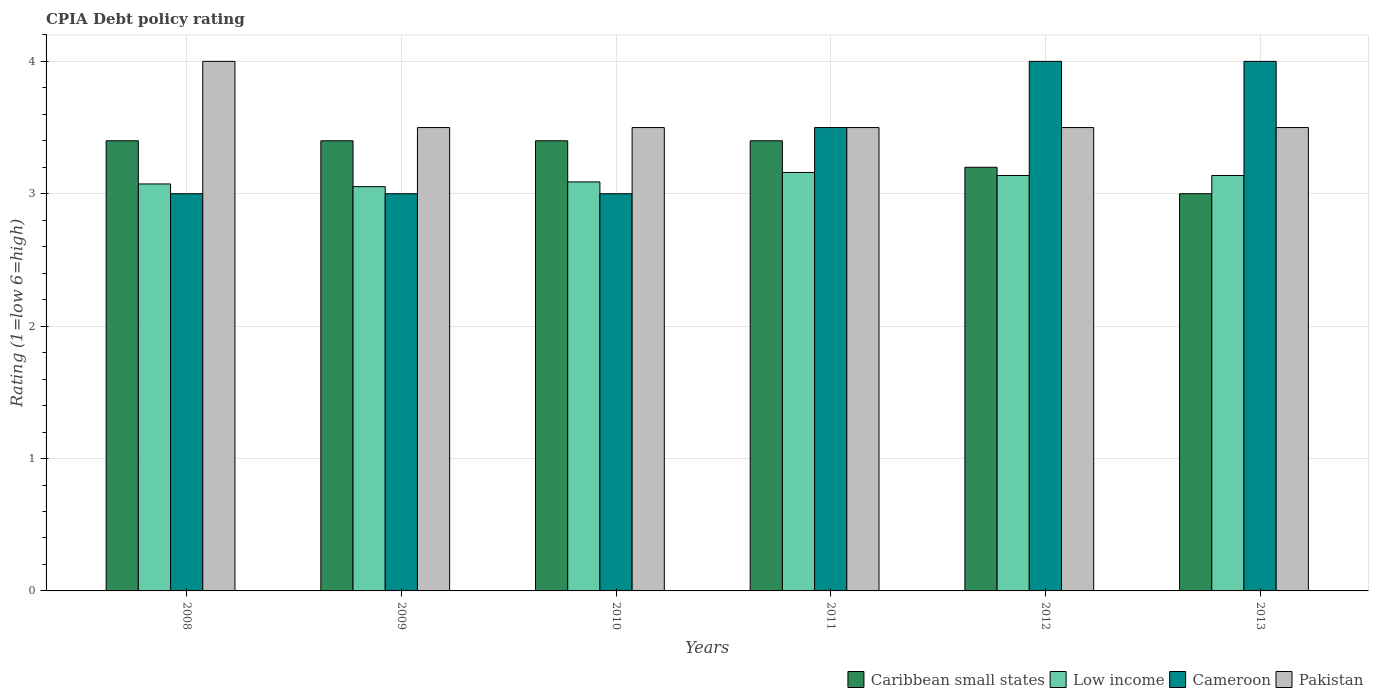How many groups of bars are there?
Offer a terse response. 6. What is the label of the 3rd group of bars from the left?
Your response must be concise. 2010. In how many cases, is the number of bars for a given year not equal to the number of legend labels?
Provide a succinct answer. 0. Across all years, what is the maximum CPIA rating in Pakistan?
Give a very brief answer. 4. Across all years, what is the minimum CPIA rating in Cameroon?
Your answer should be very brief. 3. In which year was the CPIA rating in Cameroon maximum?
Provide a succinct answer. 2012. What is the total CPIA rating in Pakistan in the graph?
Your answer should be very brief. 21.5. What is the difference between the CPIA rating in Caribbean small states in 2011 and that in 2012?
Offer a terse response. 0.2. What is the difference between the CPIA rating in Caribbean small states in 2010 and the CPIA rating in Cameroon in 2009?
Provide a succinct answer. 0.4. What is the average CPIA rating in Cameroon per year?
Your answer should be compact. 3.42. Is the difference between the CPIA rating in Cameroon in 2010 and 2013 greater than the difference between the CPIA rating in Pakistan in 2010 and 2013?
Keep it short and to the point. No. What is the difference between the highest and the second highest CPIA rating in Pakistan?
Provide a short and direct response. 0.5. What is the difference between the highest and the lowest CPIA rating in Caribbean small states?
Keep it short and to the point. 0.4. In how many years, is the CPIA rating in Caribbean small states greater than the average CPIA rating in Caribbean small states taken over all years?
Provide a short and direct response. 4. Is it the case that in every year, the sum of the CPIA rating in Low income and CPIA rating in Caribbean small states is greater than the sum of CPIA rating in Cameroon and CPIA rating in Pakistan?
Make the answer very short. No. What does the 4th bar from the left in 2011 represents?
Keep it short and to the point. Pakistan. What does the 4th bar from the right in 2008 represents?
Provide a short and direct response. Caribbean small states. How many years are there in the graph?
Provide a succinct answer. 6. Where does the legend appear in the graph?
Keep it short and to the point. Bottom right. How many legend labels are there?
Provide a short and direct response. 4. What is the title of the graph?
Your answer should be very brief. CPIA Debt policy rating. What is the label or title of the X-axis?
Provide a succinct answer. Years. What is the label or title of the Y-axis?
Give a very brief answer. Rating (1=low 6=high). What is the Rating (1=low 6=high) of Low income in 2008?
Your answer should be compact. 3.07. What is the Rating (1=low 6=high) in Pakistan in 2008?
Keep it short and to the point. 4. What is the Rating (1=low 6=high) of Caribbean small states in 2009?
Provide a succinct answer. 3.4. What is the Rating (1=low 6=high) of Low income in 2009?
Your response must be concise. 3.05. What is the Rating (1=low 6=high) in Low income in 2010?
Provide a short and direct response. 3.09. What is the Rating (1=low 6=high) in Cameroon in 2010?
Provide a succinct answer. 3. What is the Rating (1=low 6=high) in Pakistan in 2010?
Ensure brevity in your answer.  3.5. What is the Rating (1=low 6=high) of Caribbean small states in 2011?
Ensure brevity in your answer.  3.4. What is the Rating (1=low 6=high) in Low income in 2011?
Your response must be concise. 3.16. What is the Rating (1=low 6=high) of Pakistan in 2011?
Offer a very short reply. 3.5. What is the Rating (1=low 6=high) of Low income in 2012?
Provide a short and direct response. 3.14. What is the Rating (1=low 6=high) in Caribbean small states in 2013?
Your answer should be very brief. 3. What is the Rating (1=low 6=high) in Low income in 2013?
Offer a terse response. 3.14. What is the Rating (1=low 6=high) of Cameroon in 2013?
Give a very brief answer. 4. What is the Rating (1=low 6=high) of Pakistan in 2013?
Your answer should be compact. 3.5. Across all years, what is the maximum Rating (1=low 6=high) in Low income?
Give a very brief answer. 3.16. Across all years, what is the minimum Rating (1=low 6=high) of Caribbean small states?
Ensure brevity in your answer.  3. Across all years, what is the minimum Rating (1=low 6=high) in Low income?
Ensure brevity in your answer.  3.05. Across all years, what is the minimum Rating (1=low 6=high) of Cameroon?
Provide a succinct answer. 3. What is the total Rating (1=low 6=high) of Caribbean small states in the graph?
Offer a terse response. 19.8. What is the total Rating (1=low 6=high) in Low income in the graph?
Ensure brevity in your answer.  18.65. What is the total Rating (1=low 6=high) of Cameroon in the graph?
Ensure brevity in your answer.  20.5. What is the total Rating (1=low 6=high) of Pakistan in the graph?
Ensure brevity in your answer.  21.5. What is the difference between the Rating (1=low 6=high) of Caribbean small states in 2008 and that in 2009?
Offer a terse response. 0. What is the difference between the Rating (1=low 6=high) in Low income in 2008 and that in 2009?
Your answer should be compact. 0.02. What is the difference between the Rating (1=low 6=high) of Cameroon in 2008 and that in 2009?
Offer a very short reply. 0. What is the difference between the Rating (1=low 6=high) of Pakistan in 2008 and that in 2009?
Make the answer very short. 0.5. What is the difference between the Rating (1=low 6=high) in Low income in 2008 and that in 2010?
Provide a short and direct response. -0.02. What is the difference between the Rating (1=low 6=high) in Cameroon in 2008 and that in 2010?
Your answer should be very brief. 0. What is the difference between the Rating (1=low 6=high) of Caribbean small states in 2008 and that in 2011?
Offer a terse response. 0. What is the difference between the Rating (1=low 6=high) in Low income in 2008 and that in 2011?
Give a very brief answer. -0.09. What is the difference between the Rating (1=low 6=high) in Pakistan in 2008 and that in 2011?
Offer a terse response. 0.5. What is the difference between the Rating (1=low 6=high) of Low income in 2008 and that in 2012?
Offer a terse response. -0.06. What is the difference between the Rating (1=low 6=high) in Caribbean small states in 2008 and that in 2013?
Give a very brief answer. 0.4. What is the difference between the Rating (1=low 6=high) in Low income in 2008 and that in 2013?
Offer a terse response. -0.06. What is the difference between the Rating (1=low 6=high) in Cameroon in 2008 and that in 2013?
Offer a terse response. -1. What is the difference between the Rating (1=low 6=high) of Caribbean small states in 2009 and that in 2010?
Your answer should be very brief. 0. What is the difference between the Rating (1=low 6=high) in Low income in 2009 and that in 2010?
Your response must be concise. -0.04. What is the difference between the Rating (1=low 6=high) of Cameroon in 2009 and that in 2010?
Your response must be concise. 0. What is the difference between the Rating (1=low 6=high) in Pakistan in 2009 and that in 2010?
Offer a very short reply. 0. What is the difference between the Rating (1=low 6=high) of Low income in 2009 and that in 2011?
Ensure brevity in your answer.  -0.11. What is the difference between the Rating (1=low 6=high) of Cameroon in 2009 and that in 2011?
Your answer should be compact. -0.5. What is the difference between the Rating (1=low 6=high) in Pakistan in 2009 and that in 2011?
Provide a succinct answer. 0. What is the difference between the Rating (1=low 6=high) in Low income in 2009 and that in 2012?
Make the answer very short. -0.08. What is the difference between the Rating (1=low 6=high) in Cameroon in 2009 and that in 2012?
Provide a succinct answer. -1. What is the difference between the Rating (1=low 6=high) of Low income in 2009 and that in 2013?
Give a very brief answer. -0.08. What is the difference between the Rating (1=low 6=high) of Low income in 2010 and that in 2011?
Your answer should be compact. -0.07. What is the difference between the Rating (1=low 6=high) of Pakistan in 2010 and that in 2011?
Make the answer very short. 0. What is the difference between the Rating (1=low 6=high) in Caribbean small states in 2010 and that in 2012?
Offer a terse response. 0.2. What is the difference between the Rating (1=low 6=high) of Low income in 2010 and that in 2012?
Your answer should be very brief. -0.05. What is the difference between the Rating (1=low 6=high) in Cameroon in 2010 and that in 2012?
Provide a succinct answer. -1. What is the difference between the Rating (1=low 6=high) of Low income in 2010 and that in 2013?
Your response must be concise. -0.05. What is the difference between the Rating (1=low 6=high) in Low income in 2011 and that in 2012?
Your answer should be compact. 0.02. What is the difference between the Rating (1=low 6=high) in Low income in 2011 and that in 2013?
Give a very brief answer. 0.02. What is the difference between the Rating (1=low 6=high) of Cameroon in 2011 and that in 2013?
Ensure brevity in your answer.  -0.5. What is the difference between the Rating (1=low 6=high) of Caribbean small states in 2012 and that in 2013?
Provide a short and direct response. 0.2. What is the difference between the Rating (1=low 6=high) in Low income in 2012 and that in 2013?
Your answer should be very brief. 0. What is the difference between the Rating (1=low 6=high) in Cameroon in 2012 and that in 2013?
Your answer should be compact. 0. What is the difference between the Rating (1=low 6=high) in Pakistan in 2012 and that in 2013?
Your response must be concise. 0. What is the difference between the Rating (1=low 6=high) of Caribbean small states in 2008 and the Rating (1=low 6=high) of Low income in 2009?
Give a very brief answer. 0.35. What is the difference between the Rating (1=low 6=high) in Caribbean small states in 2008 and the Rating (1=low 6=high) in Pakistan in 2009?
Offer a terse response. -0.1. What is the difference between the Rating (1=low 6=high) in Low income in 2008 and the Rating (1=low 6=high) in Cameroon in 2009?
Give a very brief answer. 0.07. What is the difference between the Rating (1=low 6=high) in Low income in 2008 and the Rating (1=low 6=high) in Pakistan in 2009?
Keep it short and to the point. -0.43. What is the difference between the Rating (1=low 6=high) in Caribbean small states in 2008 and the Rating (1=low 6=high) in Low income in 2010?
Keep it short and to the point. 0.31. What is the difference between the Rating (1=low 6=high) in Caribbean small states in 2008 and the Rating (1=low 6=high) in Cameroon in 2010?
Ensure brevity in your answer.  0.4. What is the difference between the Rating (1=low 6=high) of Low income in 2008 and the Rating (1=low 6=high) of Cameroon in 2010?
Give a very brief answer. 0.07. What is the difference between the Rating (1=low 6=high) of Low income in 2008 and the Rating (1=low 6=high) of Pakistan in 2010?
Offer a very short reply. -0.43. What is the difference between the Rating (1=low 6=high) of Caribbean small states in 2008 and the Rating (1=low 6=high) of Low income in 2011?
Offer a very short reply. 0.24. What is the difference between the Rating (1=low 6=high) of Low income in 2008 and the Rating (1=low 6=high) of Cameroon in 2011?
Your response must be concise. -0.43. What is the difference between the Rating (1=low 6=high) of Low income in 2008 and the Rating (1=low 6=high) of Pakistan in 2011?
Offer a very short reply. -0.43. What is the difference between the Rating (1=low 6=high) in Caribbean small states in 2008 and the Rating (1=low 6=high) in Low income in 2012?
Ensure brevity in your answer.  0.26. What is the difference between the Rating (1=low 6=high) in Caribbean small states in 2008 and the Rating (1=low 6=high) in Cameroon in 2012?
Your answer should be very brief. -0.6. What is the difference between the Rating (1=low 6=high) of Low income in 2008 and the Rating (1=low 6=high) of Cameroon in 2012?
Your answer should be compact. -0.93. What is the difference between the Rating (1=low 6=high) of Low income in 2008 and the Rating (1=low 6=high) of Pakistan in 2012?
Offer a very short reply. -0.43. What is the difference between the Rating (1=low 6=high) of Cameroon in 2008 and the Rating (1=low 6=high) of Pakistan in 2012?
Ensure brevity in your answer.  -0.5. What is the difference between the Rating (1=low 6=high) in Caribbean small states in 2008 and the Rating (1=low 6=high) in Low income in 2013?
Your answer should be very brief. 0.26. What is the difference between the Rating (1=low 6=high) in Low income in 2008 and the Rating (1=low 6=high) in Cameroon in 2013?
Offer a terse response. -0.93. What is the difference between the Rating (1=low 6=high) of Low income in 2008 and the Rating (1=low 6=high) of Pakistan in 2013?
Make the answer very short. -0.43. What is the difference between the Rating (1=low 6=high) of Caribbean small states in 2009 and the Rating (1=low 6=high) of Low income in 2010?
Offer a terse response. 0.31. What is the difference between the Rating (1=low 6=high) in Caribbean small states in 2009 and the Rating (1=low 6=high) in Pakistan in 2010?
Your answer should be compact. -0.1. What is the difference between the Rating (1=low 6=high) in Low income in 2009 and the Rating (1=low 6=high) in Cameroon in 2010?
Your response must be concise. 0.05. What is the difference between the Rating (1=low 6=high) of Low income in 2009 and the Rating (1=low 6=high) of Pakistan in 2010?
Offer a very short reply. -0.45. What is the difference between the Rating (1=low 6=high) of Cameroon in 2009 and the Rating (1=low 6=high) of Pakistan in 2010?
Your answer should be compact. -0.5. What is the difference between the Rating (1=low 6=high) of Caribbean small states in 2009 and the Rating (1=low 6=high) of Low income in 2011?
Your answer should be compact. 0.24. What is the difference between the Rating (1=low 6=high) in Caribbean small states in 2009 and the Rating (1=low 6=high) in Pakistan in 2011?
Provide a succinct answer. -0.1. What is the difference between the Rating (1=low 6=high) in Low income in 2009 and the Rating (1=low 6=high) in Cameroon in 2011?
Make the answer very short. -0.45. What is the difference between the Rating (1=low 6=high) in Low income in 2009 and the Rating (1=low 6=high) in Pakistan in 2011?
Provide a succinct answer. -0.45. What is the difference between the Rating (1=low 6=high) in Cameroon in 2009 and the Rating (1=low 6=high) in Pakistan in 2011?
Ensure brevity in your answer.  -0.5. What is the difference between the Rating (1=low 6=high) of Caribbean small states in 2009 and the Rating (1=low 6=high) of Low income in 2012?
Your answer should be compact. 0.26. What is the difference between the Rating (1=low 6=high) of Low income in 2009 and the Rating (1=low 6=high) of Cameroon in 2012?
Ensure brevity in your answer.  -0.95. What is the difference between the Rating (1=low 6=high) of Low income in 2009 and the Rating (1=low 6=high) of Pakistan in 2012?
Provide a short and direct response. -0.45. What is the difference between the Rating (1=low 6=high) in Caribbean small states in 2009 and the Rating (1=low 6=high) in Low income in 2013?
Provide a short and direct response. 0.26. What is the difference between the Rating (1=low 6=high) in Caribbean small states in 2009 and the Rating (1=low 6=high) in Cameroon in 2013?
Provide a short and direct response. -0.6. What is the difference between the Rating (1=low 6=high) of Caribbean small states in 2009 and the Rating (1=low 6=high) of Pakistan in 2013?
Keep it short and to the point. -0.1. What is the difference between the Rating (1=low 6=high) of Low income in 2009 and the Rating (1=low 6=high) of Cameroon in 2013?
Your response must be concise. -0.95. What is the difference between the Rating (1=low 6=high) in Low income in 2009 and the Rating (1=low 6=high) in Pakistan in 2013?
Give a very brief answer. -0.45. What is the difference between the Rating (1=low 6=high) in Cameroon in 2009 and the Rating (1=low 6=high) in Pakistan in 2013?
Your answer should be very brief. -0.5. What is the difference between the Rating (1=low 6=high) in Caribbean small states in 2010 and the Rating (1=low 6=high) in Low income in 2011?
Offer a very short reply. 0.24. What is the difference between the Rating (1=low 6=high) in Caribbean small states in 2010 and the Rating (1=low 6=high) in Cameroon in 2011?
Keep it short and to the point. -0.1. What is the difference between the Rating (1=low 6=high) in Low income in 2010 and the Rating (1=low 6=high) in Cameroon in 2011?
Your response must be concise. -0.41. What is the difference between the Rating (1=low 6=high) in Low income in 2010 and the Rating (1=low 6=high) in Pakistan in 2011?
Give a very brief answer. -0.41. What is the difference between the Rating (1=low 6=high) in Cameroon in 2010 and the Rating (1=low 6=high) in Pakistan in 2011?
Give a very brief answer. -0.5. What is the difference between the Rating (1=low 6=high) of Caribbean small states in 2010 and the Rating (1=low 6=high) of Low income in 2012?
Ensure brevity in your answer.  0.26. What is the difference between the Rating (1=low 6=high) of Low income in 2010 and the Rating (1=low 6=high) of Cameroon in 2012?
Your answer should be compact. -0.91. What is the difference between the Rating (1=low 6=high) in Low income in 2010 and the Rating (1=low 6=high) in Pakistan in 2012?
Keep it short and to the point. -0.41. What is the difference between the Rating (1=low 6=high) in Caribbean small states in 2010 and the Rating (1=low 6=high) in Low income in 2013?
Ensure brevity in your answer.  0.26. What is the difference between the Rating (1=low 6=high) of Low income in 2010 and the Rating (1=low 6=high) of Cameroon in 2013?
Make the answer very short. -0.91. What is the difference between the Rating (1=low 6=high) in Low income in 2010 and the Rating (1=low 6=high) in Pakistan in 2013?
Provide a short and direct response. -0.41. What is the difference between the Rating (1=low 6=high) in Cameroon in 2010 and the Rating (1=low 6=high) in Pakistan in 2013?
Give a very brief answer. -0.5. What is the difference between the Rating (1=low 6=high) in Caribbean small states in 2011 and the Rating (1=low 6=high) in Low income in 2012?
Give a very brief answer. 0.26. What is the difference between the Rating (1=low 6=high) of Caribbean small states in 2011 and the Rating (1=low 6=high) of Cameroon in 2012?
Ensure brevity in your answer.  -0.6. What is the difference between the Rating (1=low 6=high) of Low income in 2011 and the Rating (1=low 6=high) of Cameroon in 2012?
Keep it short and to the point. -0.84. What is the difference between the Rating (1=low 6=high) in Low income in 2011 and the Rating (1=low 6=high) in Pakistan in 2012?
Give a very brief answer. -0.34. What is the difference between the Rating (1=low 6=high) of Cameroon in 2011 and the Rating (1=low 6=high) of Pakistan in 2012?
Provide a short and direct response. 0. What is the difference between the Rating (1=low 6=high) of Caribbean small states in 2011 and the Rating (1=low 6=high) of Low income in 2013?
Make the answer very short. 0.26. What is the difference between the Rating (1=low 6=high) of Caribbean small states in 2011 and the Rating (1=low 6=high) of Cameroon in 2013?
Give a very brief answer. -0.6. What is the difference between the Rating (1=low 6=high) in Caribbean small states in 2011 and the Rating (1=low 6=high) in Pakistan in 2013?
Your answer should be very brief. -0.1. What is the difference between the Rating (1=low 6=high) of Low income in 2011 and the Rating (1=low 6=high) of Cameroon in 2013?
Offer a very short reply. -0.84. What is the difference between the Rating (1=low 6=high) of Low income in 2011 and the Rating (1=low 6=high) of Pakistan in 2013?
Keep it short and to the point. -0.34. What is the difference between the Rating (1=low 6=high) in Cameroon in 2011 and the Rating (1=low 6=high) in Pakistan in 2013?
Provide a short and direct response. 0. What is the difference between the Rating (1=low 6=high) of Caribbean small states in 2012 and the Rating (1=low 6=high) of Low income in 2013?
Your answer should be compact. 0.06. What is the difference between the Rating (1=low 6=high) in Caribbean small states in 2012 and the Rating (1=low 6=high) in Cameroon in 2013?
Offer a very short reply. -0.8. What is the difference between the Rating (1=low 6=high) of Caribbean small states in 2012 and the Rating (1=low 6=high) of Pakistan in 2013?
Offer a terse response. -0.3. What is the difference between the Rating (1=low 6=high) of Low income in 2012 and the Rating (1=low 6=high) of Cameroon in 2013?
Make the answer very short. -0.86. What is the difference between the Rating (1=low 6=high) of Low income in 2012 and the Rating (1=low 6=high) of Pakistan in 2013?
Make the answer very short. -0.36. What is the difference between the Rating (1=low 6=high) of Cameroon in 2012 and the Rating (1=low 6=high) of Pakistan in 2013?
Your answer should be very brief. 0.5. What is the average Rating (1=low 6=high) in Caribbean small states per year?
Your response must be concise. 3.3. What is the average Rating (1=low 6=high) of Low income per year?
Provide a succinct answer. 3.11. What is the average Rating (1=low 6=high) in Cameroon per year?
Your response must be concise. 3.42. What is the average Rating (1=low 6=high) in Pakistan per year?
Make the answer very short. 3.58. In the year 2008, what is the difference between the Rating (1=low 6=high) in Caribbean small states and Rating (1=low 6=high) in Low income?
Ensure brevity in your answer.  0.33. In the year 2008, what is the difference between the Rating (1=low 6=high) in Caribbean small states and Rating (1=low 6=high) in Cameroon?
Give a very brief answer. 0.4. In the year 2008, what is the difference between the Rating (1=low 6=high) of Caribbean small states and Rating (1=low 6=high) of Pakistan?
Provide a short and direct response. -0.6. In the year 2008, what is the difference between the Rating (1=low 6=high) of Low income and Rating (1=low 6=high) of Cameroon?
Ensure brevity in your answer.  0.07. In the year 2008, what is the difference between the Rating (1=low 6=high) of Low income and Rating (1=low 6=high) of Pakistan?
Your answer should be very brief. -0.93. In the year 2009, what is the difference between the Rating (1=low 6=high) in Caribbean small states and Rating (1=low 6=high) in Low income?
Offer a terse response. 0.35. In the year 2009, what is the difference between the Rating (1=low 6=high) in Caribbean small states and Rating (1=low 6=high) in Pakistan?
Provide a short and direct response. -0.1. In the year 2009, what is the difference between the Rating (1=low 6=high) of Low income and Rating (1=low 6=high) of Cameroon?
Provide a short and direct response. 0.05. In the year 2009, what is the difference between the Rating (1=low 6=high) in Low income and Rating (1=low 6=high) in Pakistan?
Provide a succinct answer. -0.45. In the year 2010, what is the difference between the Rating (1=low 6=high) of Caribbean small states and Rating (1=low 6=high) of Low income?
Make the answer very short. 0.31. In the year 2010, what is the difference between the Rating (1=low 6=high) in Caribbean small states and Rating (1=low 6=high) in Pakistan?
Your response must be concise. -0.1. In the year 2010, what is the difference between the Rating (1=low 6=high) of Low income and Rating (1=low 6=high) of Cameroon?
Your answer should be compact. 0.09. In the year 2010, what is the difference between the Rating (1=low 6=high) in Low income and Rating (1=low 6=high) in Pakistan?
Make the answer very short. -0.41. In the year 2011, what is the difference between the Rating (1=low 6=high) in Caribbean small states and Rating (1=low 6=high) in Low income?
Offer a terse response. 0.24. In the year 2011, what is the difference between the Rating (1=low 6=high) in Caribbean small states and Rating (1=low 6=high) in Cameroon?
Ensure brevity in your answer.  -0.1. In the year 2011, what is the difference between the Rating (1=low 6=high) in Low income and Rating (1=low 6=high) in Cameroon?
Provide a short and direct response. -0.34. In the year 2011, what is the difference between the Rating (1=low 6=high) of Low income and Rating (1=low 6=high) of Pakistan?
Ensure brevity in your answer.  -0.34. In the year 2011, what is the difference between the Rating (1=low 6=high) of Cameroon and Rating (1=low 6=high) of Pakistan?
Keep it short and to the point. 0. In the year 2012, what is the difference between the Rating (1=low 6=high) in Caribbean small states and Rating (1=low 6=high) in Low income?
Provide a short and direct response. 0.06. In the year 2012, what is the difference between the Rating (1=low 6=high) in Low income and Rating (1=low 6=high) in Cameroon?
Offer a terse response. -0.86. In the year 2012, what is the difference between the Rating (1=low 6=high) of Low income and Rating (1=low 6=high) of Pakistan?
Make the answer very short. -0.36. In the year 2013, what is the difference between the Rating (1=low 6=high) of Caribbean small states and Rating (1=low 6=high) of Low income?
Make the answer very short. -0.14. In the year 2013, what is the difference between the Rating (1=low 6=high) in Caribbean small states and Rating (1=low 6=high) in Cameroon?
Keep it short and to the point. -1. In the year 2013, what is the difference between the Rating (1=low 6=high) in Caribbean small states and Rating (1=low 6=high) in Pakistan?
Your answer should be compact. -0.5. In the year 2013, what is the difference between the Rating (1=low 6=high) of Low income and Rating (1=low 6=high) of Cameroon?
Provide a succinct answer. -0.86. In the year 2013, what is the difference between the Rating (1=low 6=high) of Low income and Rating (1=low 6=high) of Pakistan?
Your response must be concise. -0.36. What is the ratio of the Rating (1=low 6=high) in Pakistan in 2008 to that in 2009?
Your answer should be very brief. 1.14. What is the ratio of the Rating (1=low 6=high) of Cameroon in 2008 to that in 2010?
Give a very brief answer. 1. What is the ratio of the Rating (1=low 6=high) of Pakistan in 2008 to that in 2010?
Ensure brevity in your answer.  1.14. What is the ratio of the Rating (1=low 6=high) of Caribbean small states in 2008 to that in 2011?
Offer a terse response. 1. What is the ratio of the Rating (1=low 6=high) of Low income in 2008 to that in 2011?
Your answer should be very brief. 0.97. What is the ratio of the Rating (1=low 6=high) in Pakistan in 2008 to that in 2011?
Ensure brevity in your answer.  1.14. What is the ratio of the Rating (1=low 6=high) of Caribbean small states in 2008 to that in 2012?
Provide a short and direct response. 1.06. What is the ratio of the Rating (1=low 6=high) in Low income in 2008 to that in 2012?
Keep it short and to the point. 0.98. What is the ratio of the Rating (1=low 6=high) in Caribbean small states in 2008 to that in 2013?
Provide a short and direct response. 1.13. What is the ratio of the Rating (1=low 6=high) of Low income in 2008 to that in 2013?
Offer a very short reply. 0.98. What is the ratio of the Rating (1=low 6=high) in Pakistan in 2008 to that in 2013?
Your answer should be compact. 1.14. What is the ratio of the Rating (1=low 6=high) in Caribbean small states in 2009 to that in 2010?
Keep it short and to the point. 1. What is the ratio of the Rating (1=low 6=high) of Low income in 2009 to that in 2010?
Make the answer very short. 0.99. What is the ratio of the Rating (1=low 6=high) in Low income in 2009 to that in 2011?
Keep it short and to the point. 0.97. What is the ratio of the Rating (1=low 6=high) of Cameroon in 2009 to that in 2011?
Provide a succinct answer. 0.86. What is the ratio of the Rating (1=low 6=high) of Pakistan in 2009 to that in 2011?
Keep it short and to the point. 1. What is the ratio of the Rating (1=low 6=high) in Low income in 2009 to that in 2012?
Give a very brief answer. 0.97. What is the ratio of the Rating (1=low 6=high) in Pakistan in 2009 to that in 2012?
Your answer should be compact. 1. What is the ratio of the Rating (1=low 6=high) of Caribbean small states in 2009 to that in 2013?
Ensure brevity in your answer.  1.13. What is the ratio of the Rating (1=low 6=high) of Low income in 2009 to that in 2013?
Your answer should be very brief. 0.97. What is the ratio of the Rating (1=low 6=high) in Cameroon in 2009 to that in 2013?
Offer a very short reply. 0.75. What is the ratio of the Rating (1=low 6=high) of Caribbean small states in 2010 to that in 2011?
Provide a short and direct response. 1. What is the ratio of the Rating (1=low 6=high) in Low income in 2010 to that in 2011?
Your answer should be very brief. 0.98. What is the ratio of the Rating (1=low 6=high) of Cameroon in 2010 to that in 2011?
Offer a very short reply. 0.86. What is the ratio of the Rating (1=low 6=high) of Pakistan in 2010 to that in 2011?
Offer a very short reply. 1. What is the ratio of the Rating (1=low 6=high) in Caribbean small states in 2010 to that in 2012?
Keep it short and to the point. 1.06. What is the ratio of the Rating (1=low 6=high) in Low income in 2010 to that in 2012?
Offer a very short reply. 0.98. What is the ratio of the Rating (1=low 6=high) in Cameroon in 2010 to that in 2012?
Keep it short and to the point. 0.75. What is the ratio of the Rating (1=low 6=high) in Pakistan in 2010 to that in 2012?
Give a very brief answer. 1. What is the ratio of the Rating (1=low 6=high) of Caribbean small states in 2010 to that in 2013?
Provide a succinct answer. 1.13. What is the ratio of the Rating (1=low 6=high) in Low income in 2010 to that in 2013?
Offer a terse response. 0.98. What is the ratio of the Rating (1=low 6=high) in Caribbean small states in 2011 to that in 2012?
Give a very brief answer. 1.06. What is the ratio of the Rating (1=low 6=high) of Low income in 2011 to that in 2012?
Give a very brief answer. 1.01. What is the ratio of the Rating (1=low 6=high) of Caribbean small states in 2011 to that in 2013?
Provide a short and direct response. 1.13. What is the ratio of the Rating (1=low 6=high) in Low income in 2011 to that in 2013?
Your response must be concise. 1.01. What is the ratio of the Rating (1=low 6=high) in Cameroon in 2011 to that in 2013?
Your response must be concise. 0.88. What is the ratio of the Rating (1=low 6=high) in Caribbean small states in 2012 to that in 2013?
Provide a succinct answer. 1.07. What is the ratio of the Rating (1=low 6=high) of Pakistan in 2012 to that in 2013?
Your answer should be compact. 1. What is the difference between the highest and the second highest Rating (1=low 6=high) of Caribbean small states?
Ensure brevity in your answer.  0. What is the difference between the highest and the second highest Rating (1=low 6=high) in Low income?
Offer a very short reply. 0.02. What is the difference between the highest and the second highest Rating (1=low 6=high) of Pakistan?
Provide a succinct answer. 0.5. What is the difference between the highest and the lowest Rating (1=low 6=high) of Caribbean small states?
Offer a terse response. 0.4. What is the difference between the highest and the lowest Rating (1=low 6=high) in Low income?
Make the answer very short. 0.11. What is the difference between the highest and the lowest Rating (1=low 6=high) of Cameroon?
Make the answer very short. 1. 